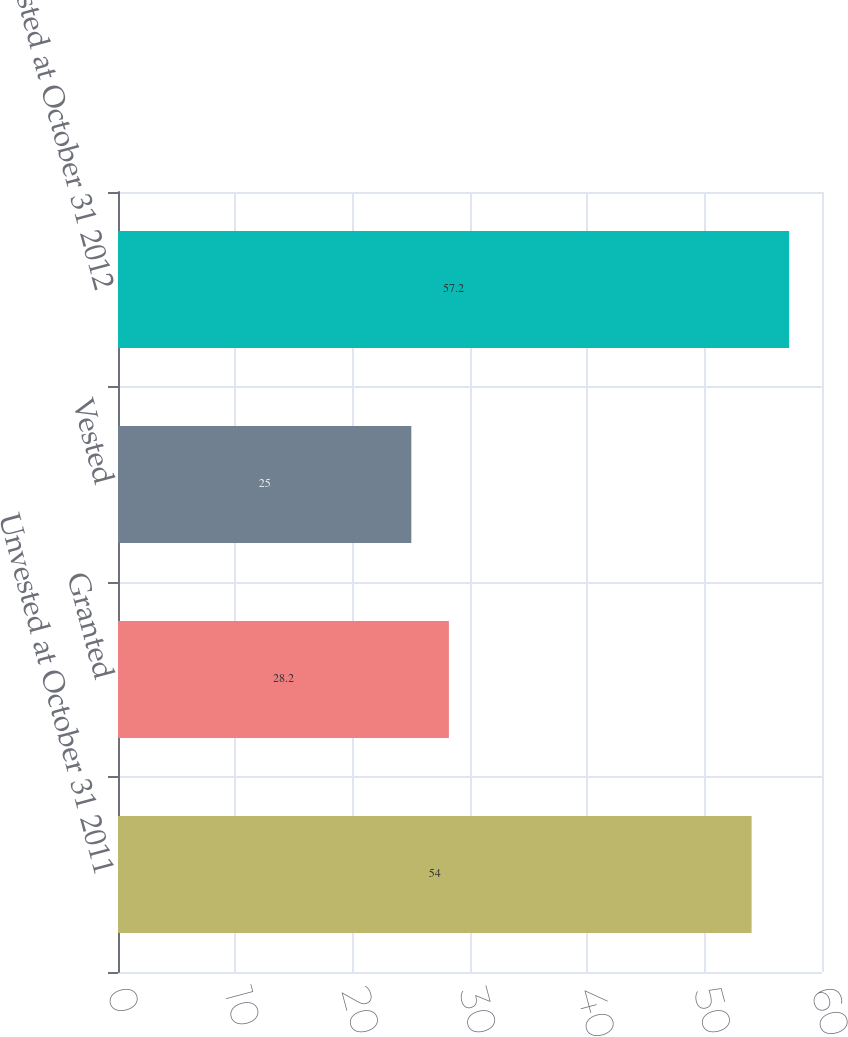Convert chart. <chart><loc_0><loc_0><loc_500><loc_500><bar_chart><fcel>Unvested at October 31 2011<fcel>Granted<fcel>Vested<fcel>Unvested at October 31 2012<nl><fcel>54<fcel>28.2<fcel>25<fcel>57.2<nl></chart> 